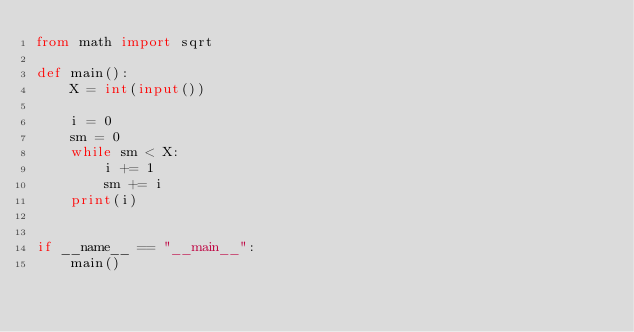<code> <loc_0><loc_0><loc_500><loc_500><_Python_>from math import sqrt

def main():
    X = int(input())

    i = 0
    sm = 0
    while sm < X:
        i += 1
        sm += i
    print(i)


if __name__ == "__main__":
    main()</code> 